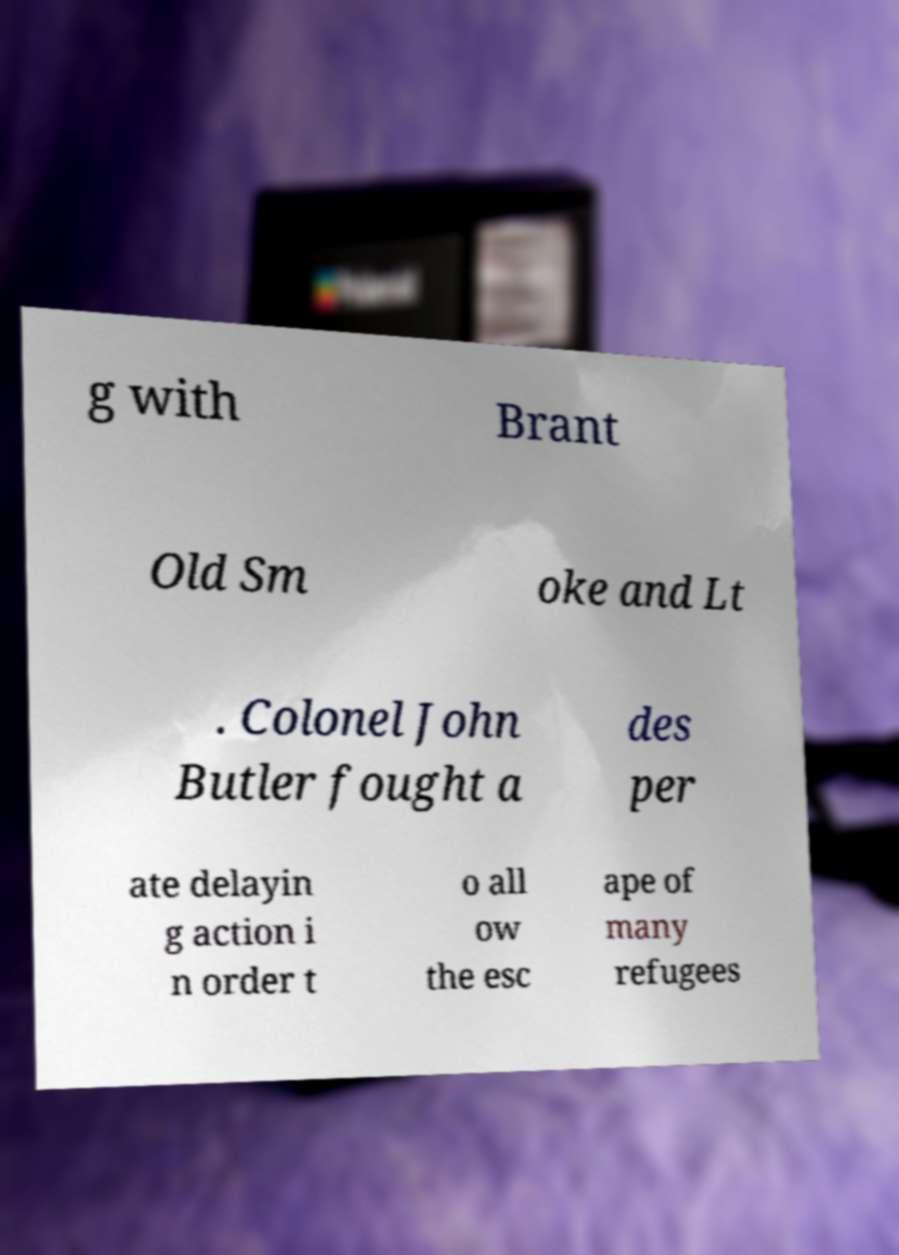I need the written content from this picture converted into text. Can you do that? g with Brant Old Sm oke and Lt . Colonel John Butler fought a des per ate delayin g action i n order t o all ow the esc ape of many refugees 